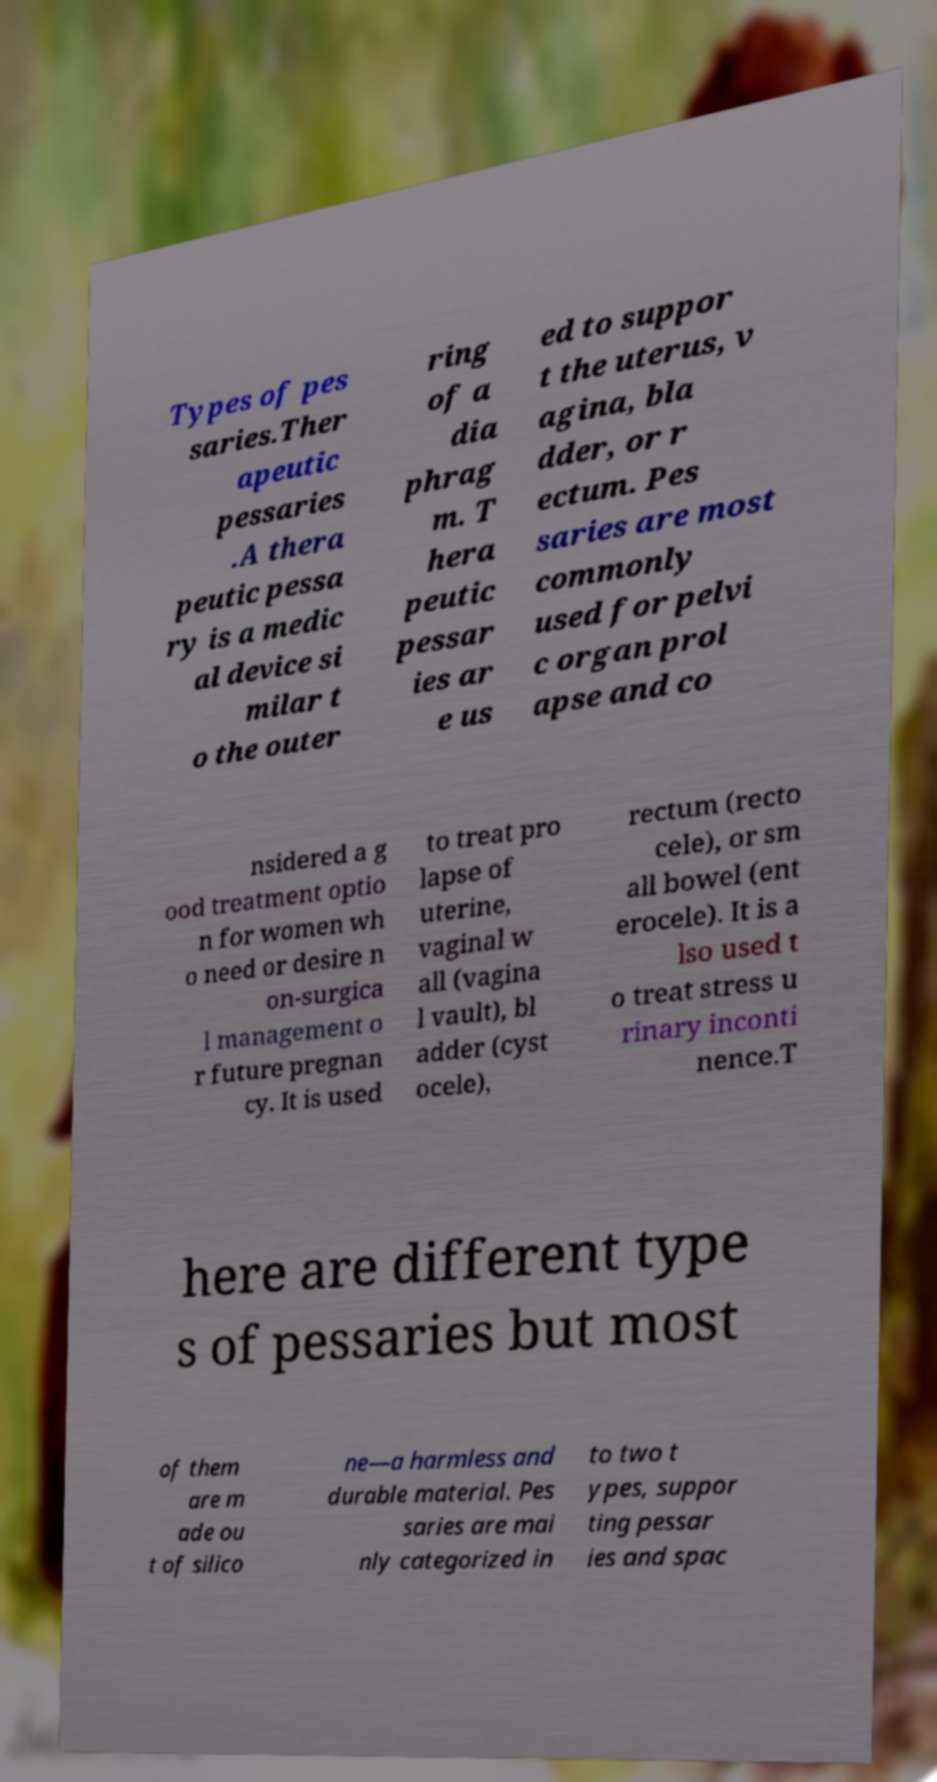Please read and relay the text visible in this image. What does it say? Types of pes saries.Ther apeutic pessaries .A thera peutic pessa ry is a medic al device si milar t o the outer ring of a dia phrag m. T hera peutic pessar ies ar e us ed to suppor t the uterus, v agina, bla dder, or r ectum. Pes saries are most commonly used for pelvi c organ prol apse and co nsidered a g ood treatment optio n for women wh o need or desire n on-surgica l management o r future pregnan cy. It is used to treat pro lapse of uterine, vaginal w all (vagina l vault), bl adder (cyst ocele), rectum (recto cele), or sm all bowel (ent erocele). It is a lso used t o treat stress u rinary inconti nence.T here are different type s of pessaries but most of them are m ade ou t of silico ne—a harmless and durable material. Pes saries are mai nly categorized in to two t ypes, suppor ting pessar ies and spac 